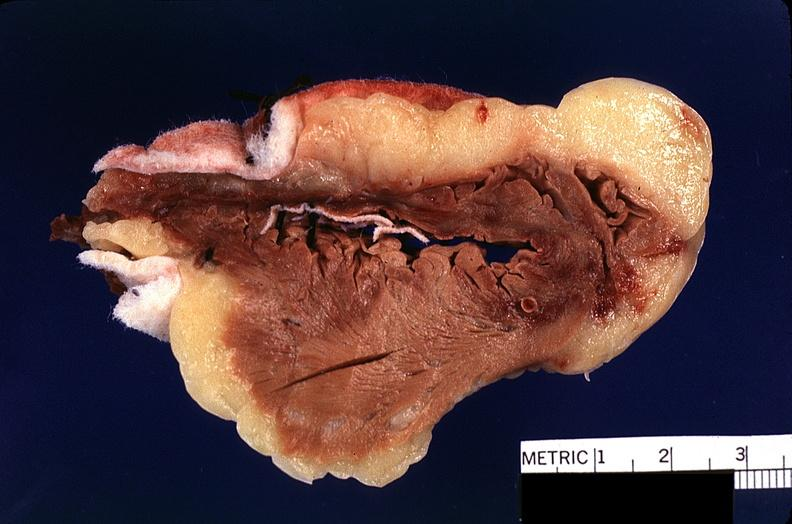does this image show heart, myocardial infarction, surgery to repair interventricular septum rupture?
Answer the question using a single word or phrase. Yes 